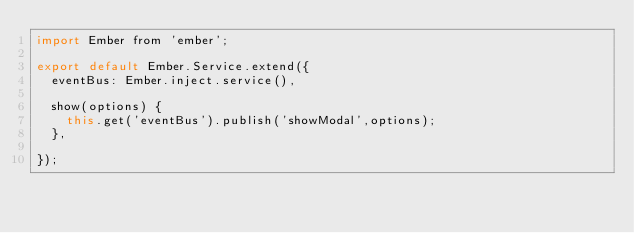<code> <loc_0><loc_0><loc_500><loc_500><_JavaScript_>import Ember from 'ember';

export default Ember.Service.extend({
  eventBus: Ember.inject.service(),
  
  show(options) {
    this.get('eventBus').publish('showModal',options);
  },
  
});
</code> 